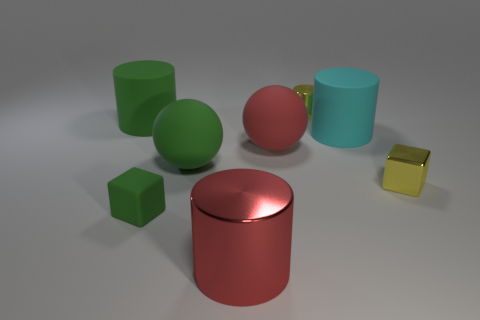What number of large yellow spheres are made of the same material as the yellow block?
Keep it short and to the point. 0. What shape is the object that is the same color as the metallic cube?
Your response must be concise. Cylinder. Are there any large green matte objects that have the same shape as the small green object?
Offer a terse response. No. There is a cyan matte object that is the same size as the red matte thing; what is its shape?
Provide a succinct answer. Cylinder. Does the small shiny block have the same color as the small block that is in front of the tiny yellow shiny cube?
Make the answer very short. No. What number of tiny yellow shiny cubes are in front of the cube right of the small yellow cylinder?
Provide a succinct answer. 0. There is a thing that is behind the cyan object and to the right of the matte block; what size is it?
Provide a short and direct response. Small. Is there a block that has the same size as the red matte ball?
Make the answer very short. No. Are there more tiny metallic cylinders that are on the left side of the tiny green matte thing than yellow cylinders right of the metal cube?
Provide a short and direct response. No. Is the yellow cylinder made of the same material as the cube to the left of the red metal cylinder?
Your answer should be very brief. No. 